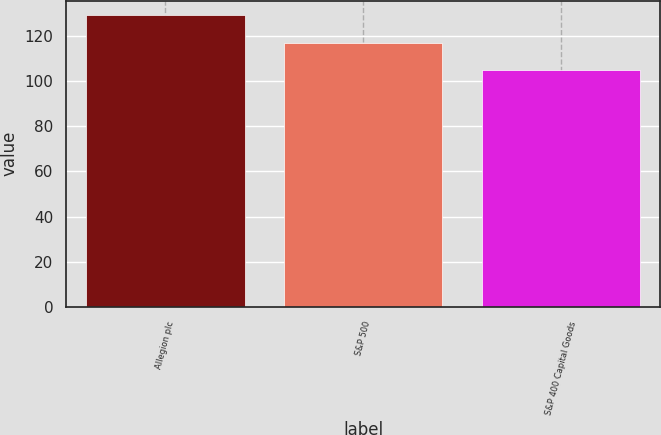Convert chart. <chart><loc_0><loc_0><loc_500><loc_500><bar_chart><fcel>Allegion plc<fcel>S&P 500<fcel>S&P 400 Capital Goods<nl><fcel>129.03<fcel>116.57<fcel>104.84<nl></chart> 